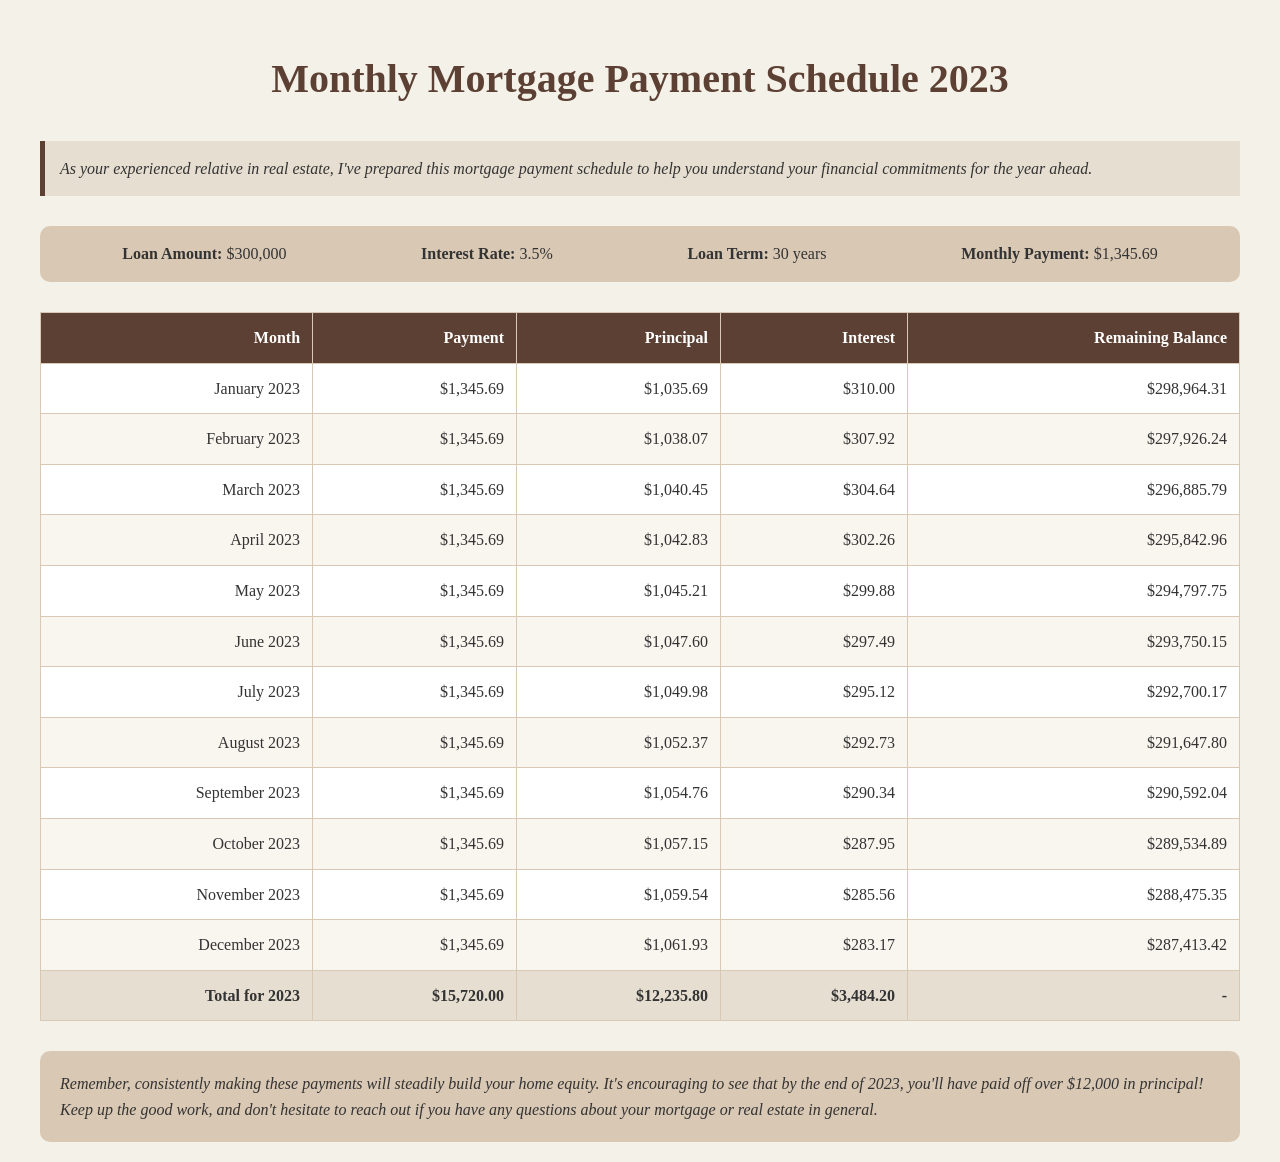what is the loan amount? The loan amount is specified in the loan details section of the document.
Answer: $300,000 what is the interest rate? The interest rate is indicated alongside the loan amount and term.
Answer: 3.5% how long is the loan term? The loan term represents the duration over which the loan will be repaid.
Answer: 30 years what is the monthly payment amount? The monthly payment is calculated based on the loan amount, interest rate, and term and appears in the loan details section.
Answer: $1,345.69 what is the principal paid in January 2023? The principal for January 2023 is shown in the monthly breakdown of the mortgage payment schedule.
Answer: $1,035.69 what is the total principal paid by the end of 2023? The total principal is calculated by summing the principal payments for each month in 2023, which is stated in the total row.
Answer: $12,235.80 how much interest is paid in February 2023? The interest paid for February 2023 can be found in the breakdown of that month's payment.
Answer: $307.92 what is the remaining balance at the end of December 2023? The remaining balance is listed after the last payment of December 2023 in the schedule.
Answer: $287,413.42 how much total will be paid in 2023? The total payment for 2023 is the sum of all monthly payments throughout the year.
Answer: $15,720.00 what advice is given at the end of the document? The advice contains insights on building home equity and encouragement based on the payments made.
Answer: Build home equity 